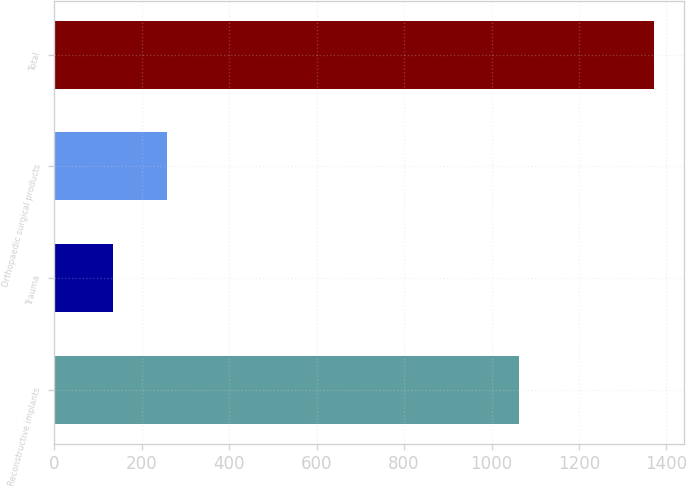Convert chart to OTSL. <chart><loc_0><loc_0><loc_500><loc_500><bar_chart><fcel>Reconstructive implants<fcel>Trauma<fcel>Orthopaedic surgical products<fcel>Total<nl><fcel>1061.7<fcel>133.8<fcel>257.66<fcel>1372.4<nl></chart> 